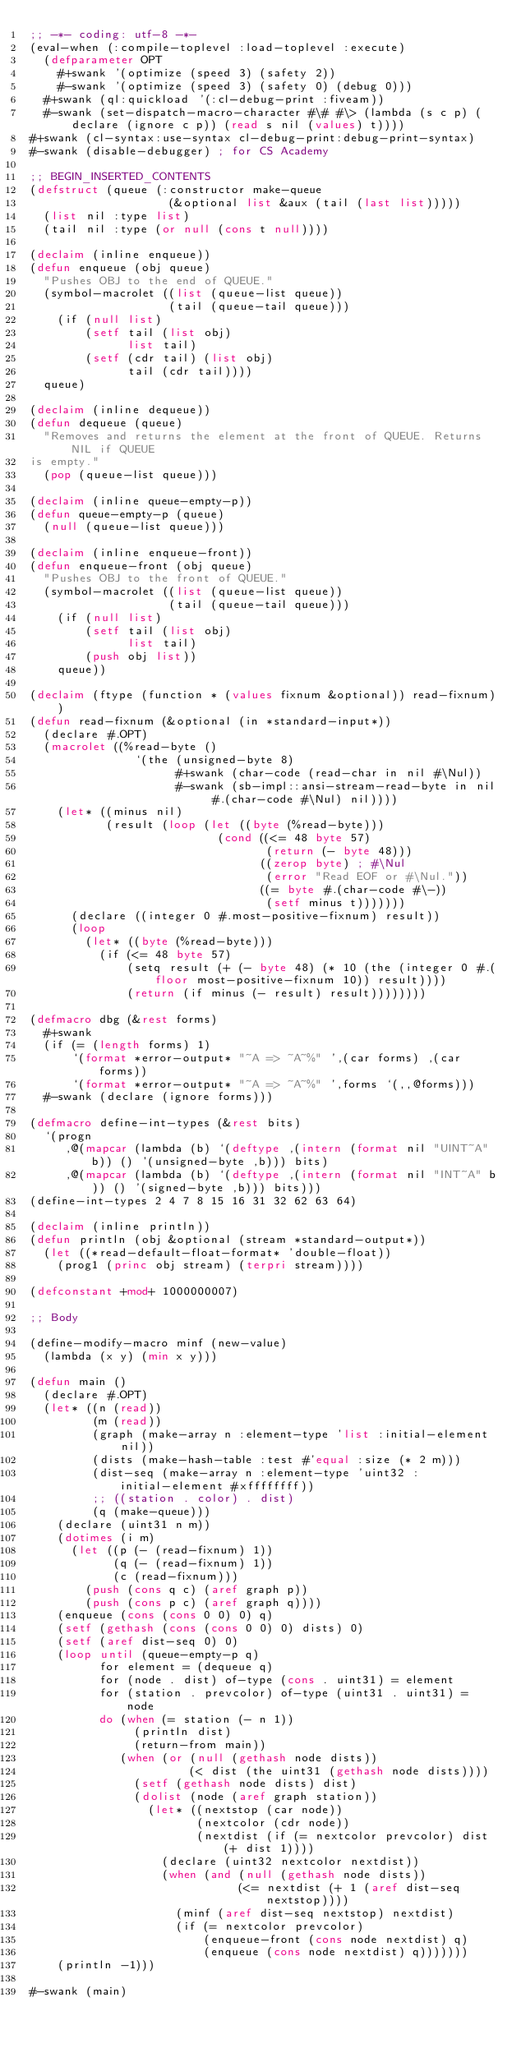<code> <loc_0><loc_0><loc_500><loc_500><_Lisp_>;; -*- coding: utf-8 -*-
(eval-when (:compile-toplevel :load-toplevel :execute)
  (defparameter OPT
    #+swank '(optimize (speed 3) (safety 2))
    #-swank '(optimize (speed 3) (safety 0) (debug 0)))
  #+swank (ql:quickload '(:cl-debug-print :fiveam))
  #-swank (set-dispatch-macro-character #\# #\> (lambda (s c p) (declare (ignore c p)) (read s nil (values) t))))
#+swank (cl-syntax:use-syntax cl-debug-print:debug-print-syntax)
#-swank (disable-debugger) ; for CS Academy

;; BEGIN_INSERTED_CONTENTS
(defstruct (queue (:constructor make-queue
                    (&optional list &aux (tail (last list)))))
  (list nil :type list)
  (tail nil :type (or null (cons t null))))

(declaim (inline enqueue))
(defun enqueue (obj queue)
  "Pushes OBJ to the end of QUEUE."
  (symbol-macrolet ((list (queue-list queue))
                    (tail (queue-tail queue)))
    (if (null list)
        (setf tail (list obj)
              list tail)
        (setf (cdr tail) (list obj)
              tail (cdr tail))))
  queue)

(declaim (inline dequeue))
(defun dequeue (queue)
  "Removes and returns the element at the front of QUEUE. Returns NIL if QUEUE
is empty."
  (pop (queue-list queue)))

(declaim (inline queue-empty-p))
(defun queue-empty-p (queue)
  (null (queue-list queue)))

(declaim (inline enqueue-front))
(defun enqueue-front (obj queue)
  "Pushes OBJ to the front of QUEUE."
  (symbol-macrolet ((list (queue-list queue))
                    (tail (queue-tail queue)))
    (if (null list)
        (setf tail (list obj)
              list tail)
        (push obj list))
    queue))

(declaim (ftype (function * (values fixnum &optional)) read-fixnum))
(defun read-fixnum (&optional (in *standard-input*))
  (declare #.OPT)
  (macrolet ((%read-byte ()
               `(the (unsigned-byte 8)
                     #+swank (char-code (read-char in nil #\Nul))
                     #-swank (sb-impl::ansi-stream-read-byte in nil #.(char-code #\Nul) nil))))
    (let* ((minus nil)
           (result (loop (let ((byte (%read-byte)))
                           (cond ((<= 48 byte 57)
                                  (return (- byte 48)))
                                 ((zerop byte) ; #\Nul
                                  (error "Read EOF or #\Nul."))
                                 ((= byte #.(char-code #\-))
                                  (setf minus t)))))))
      (declare ((integer 0 #.most-positive-fixnum) result))
      (loop
        (let* ((byte (%read-byte)))
          (if (<= 48 byte 57)
              (setq result (+ (- byte 48) (* 10 (the (integer 0 #.(floor most-positive-fixnum 10)) result))))
              (return (if minus (- result) result))))))))

(defmacro dbg (&rest forms)
  #+swank
  (if (= (length forms) 1)
      `(format *error-output* "~A => ~A~%" ',(car forms) ,(car forms))
      `(format *error-output* "~A => ~A~%" ',forms `(,,@forms)))
  #-swank (declare (ignore forms)))

(defmacro define-int-types (&rest bits)
  `(progn
     ,@(mapcar (lambda (b) `(deftype ,(intern (format nil "UINT~A" b)) () '(unsigned-byte ,b))) bits)
     ,@(mapcar (lambda (b) `(deftype ,(intern (format nil "INT~A" b)) () '(signed-byte ,b))) bits)))
(define-int-types 2 4 7 8 15 16 31 32 62 63 64)

(declaim (inline println))
(defun println (obj &optional (stream *standard-output*))
  (let ((*read-default-float-format* 'double-float))
    (prog1 (princ obj stream) (terpri stream))))

(defconstant +mod+ 1000000007)

;; Body

(define-modify-macro minf (new-value)
  (lambda (x y) (min x y)))

(defun main ()
  (declare #.OPT)
  (let* ((n (read))
         (m (read))
         (graph (make-array n :element-type 'list :initial-element nil))
         (dists (make-hash-table :test #'equal :size (* 2 m)))
         (dist-seq (make-array n :element-type 'uint32 :initial-element #xffffffff))
         ;; ((station . color) . dist)
         (q (make-queue)))
    (declare (uint31 n m))
    (dotimes (i m)
      (let ((p (- (read-fixnum) 1))
            (q (- (read-fixnum) 1))
            (c (read-fixnum)))
        (push (cons q c) (aref graph p))
        (push (cons p c) (aref graph q))))
    (enqueue (cons (cons 0 0) 0) q)
    (setf (gethash (cons (cons 0 0) 0) dists) 0)
    (setf (aref dist-seq 0) 0)
    (loop until (queue-empty-p q)
          for element = (dequeue q)
          for (node . dist) of-type (cons . uint31) = element
          for (station . prevcolor) of-type (uint31 . uint31) = node
          do (when (= station (- n 1))
               (println dist)
               (return-from main))
             (when (or (null (gethash node dists))
                       (< dist (the uint31 (gethash node dists))))
               (setf (gethash node dists) dist)
               (dolist (node (aref graph station))
                 (let* ((nextstop (car node))
                        (nextcolor (cdr node))
                        (nextdist (if (= nextcolor prevcolor) dist (+ dist 1))))
                   (declare (uint32 nextcolor nextdist))
                   (when (and (null (gethash node dists))
                              (<= nextdist (+ 1 (aref dist-seq nextstop))))
                     (minf (aref dist-seq nextstop) nextdist)
                     (if (= nextcolor prevcolor)
                         (enqueue-front (cons node nextdist) q)
                         (enqueue (cons node nextdist) q)))))))
    (println -1)))

#-swank (main)
</code> 